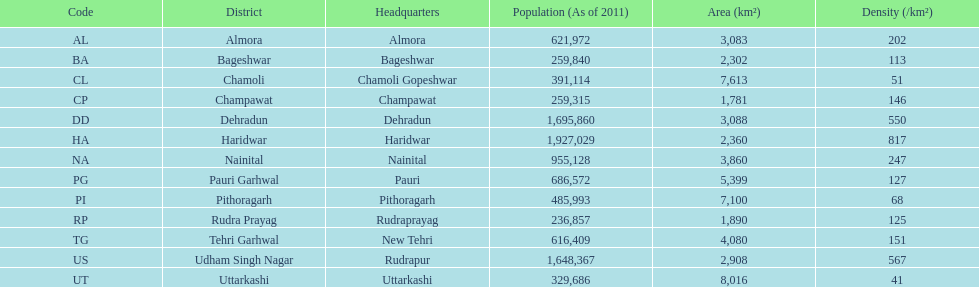If an individual was based in almora, what would be their district? Almora. 